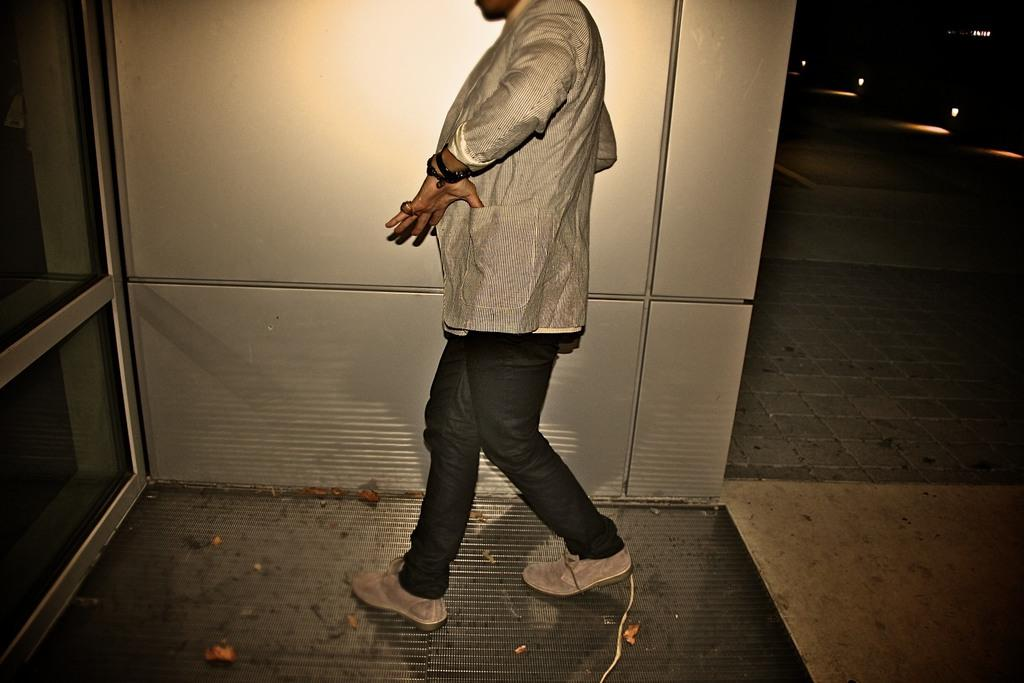Who or what is in the center of the image? There is a person in the center of the image. What can be seen on the left side of the image? There is a glass window on the left side of the image. What is located on the right side of the image? There are lights on the right side of the image. What type of surface is visible in the image? There is a floor visible in the image. What is present at the bottom of the image? Dry leaves are present at the bottom of the image. How many clocks are visible in the image? There are no clocks visible in the image. What type of cloud can be seen in the image? There is no cloud present in the image. 